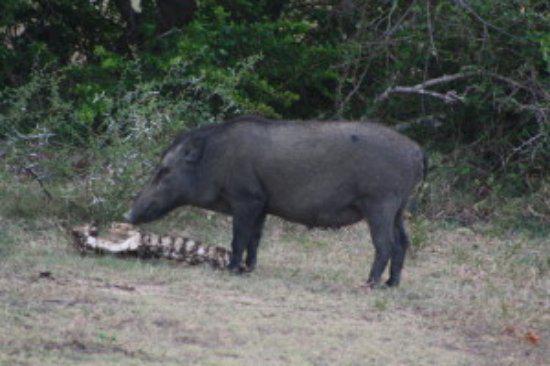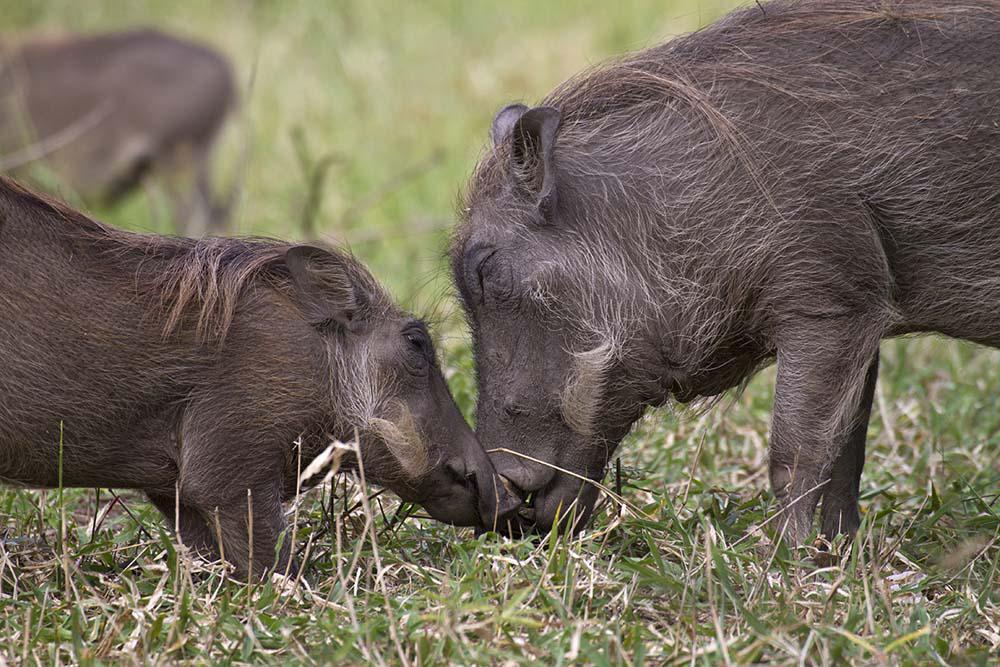The first image is the image on the left, the second image is the image on the right. Examine the images to the left and right. Is the description "An image shows two warthogs face-to-face in the foreground, and no warthogs face-to-face in the background." accurate? Answer yes or no. Yes. The first image is the image on the left, the second image is the image on the right. Considering the images on both sides, is "Two of the animals in the image on the left are butting heads." valid? Answer yes or no. No. 